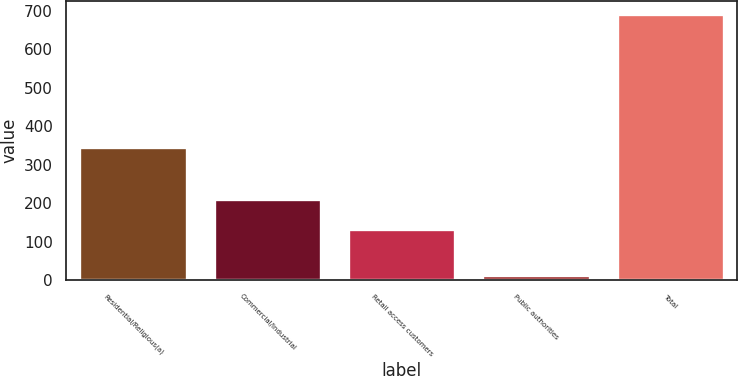Convert chart to OTSL. <chart><loc_0><loc_0><loc_500><loc_500><bar_chart><fcel>Residential/Religious(a)<fcel>Commercial/Industrial<fcel>Retail access customers<fcel>Public authorities<fcel>Total<nl><fcel>347<fcel>211<fcel>132<fcel>12<fcel>692<nl></chart> 